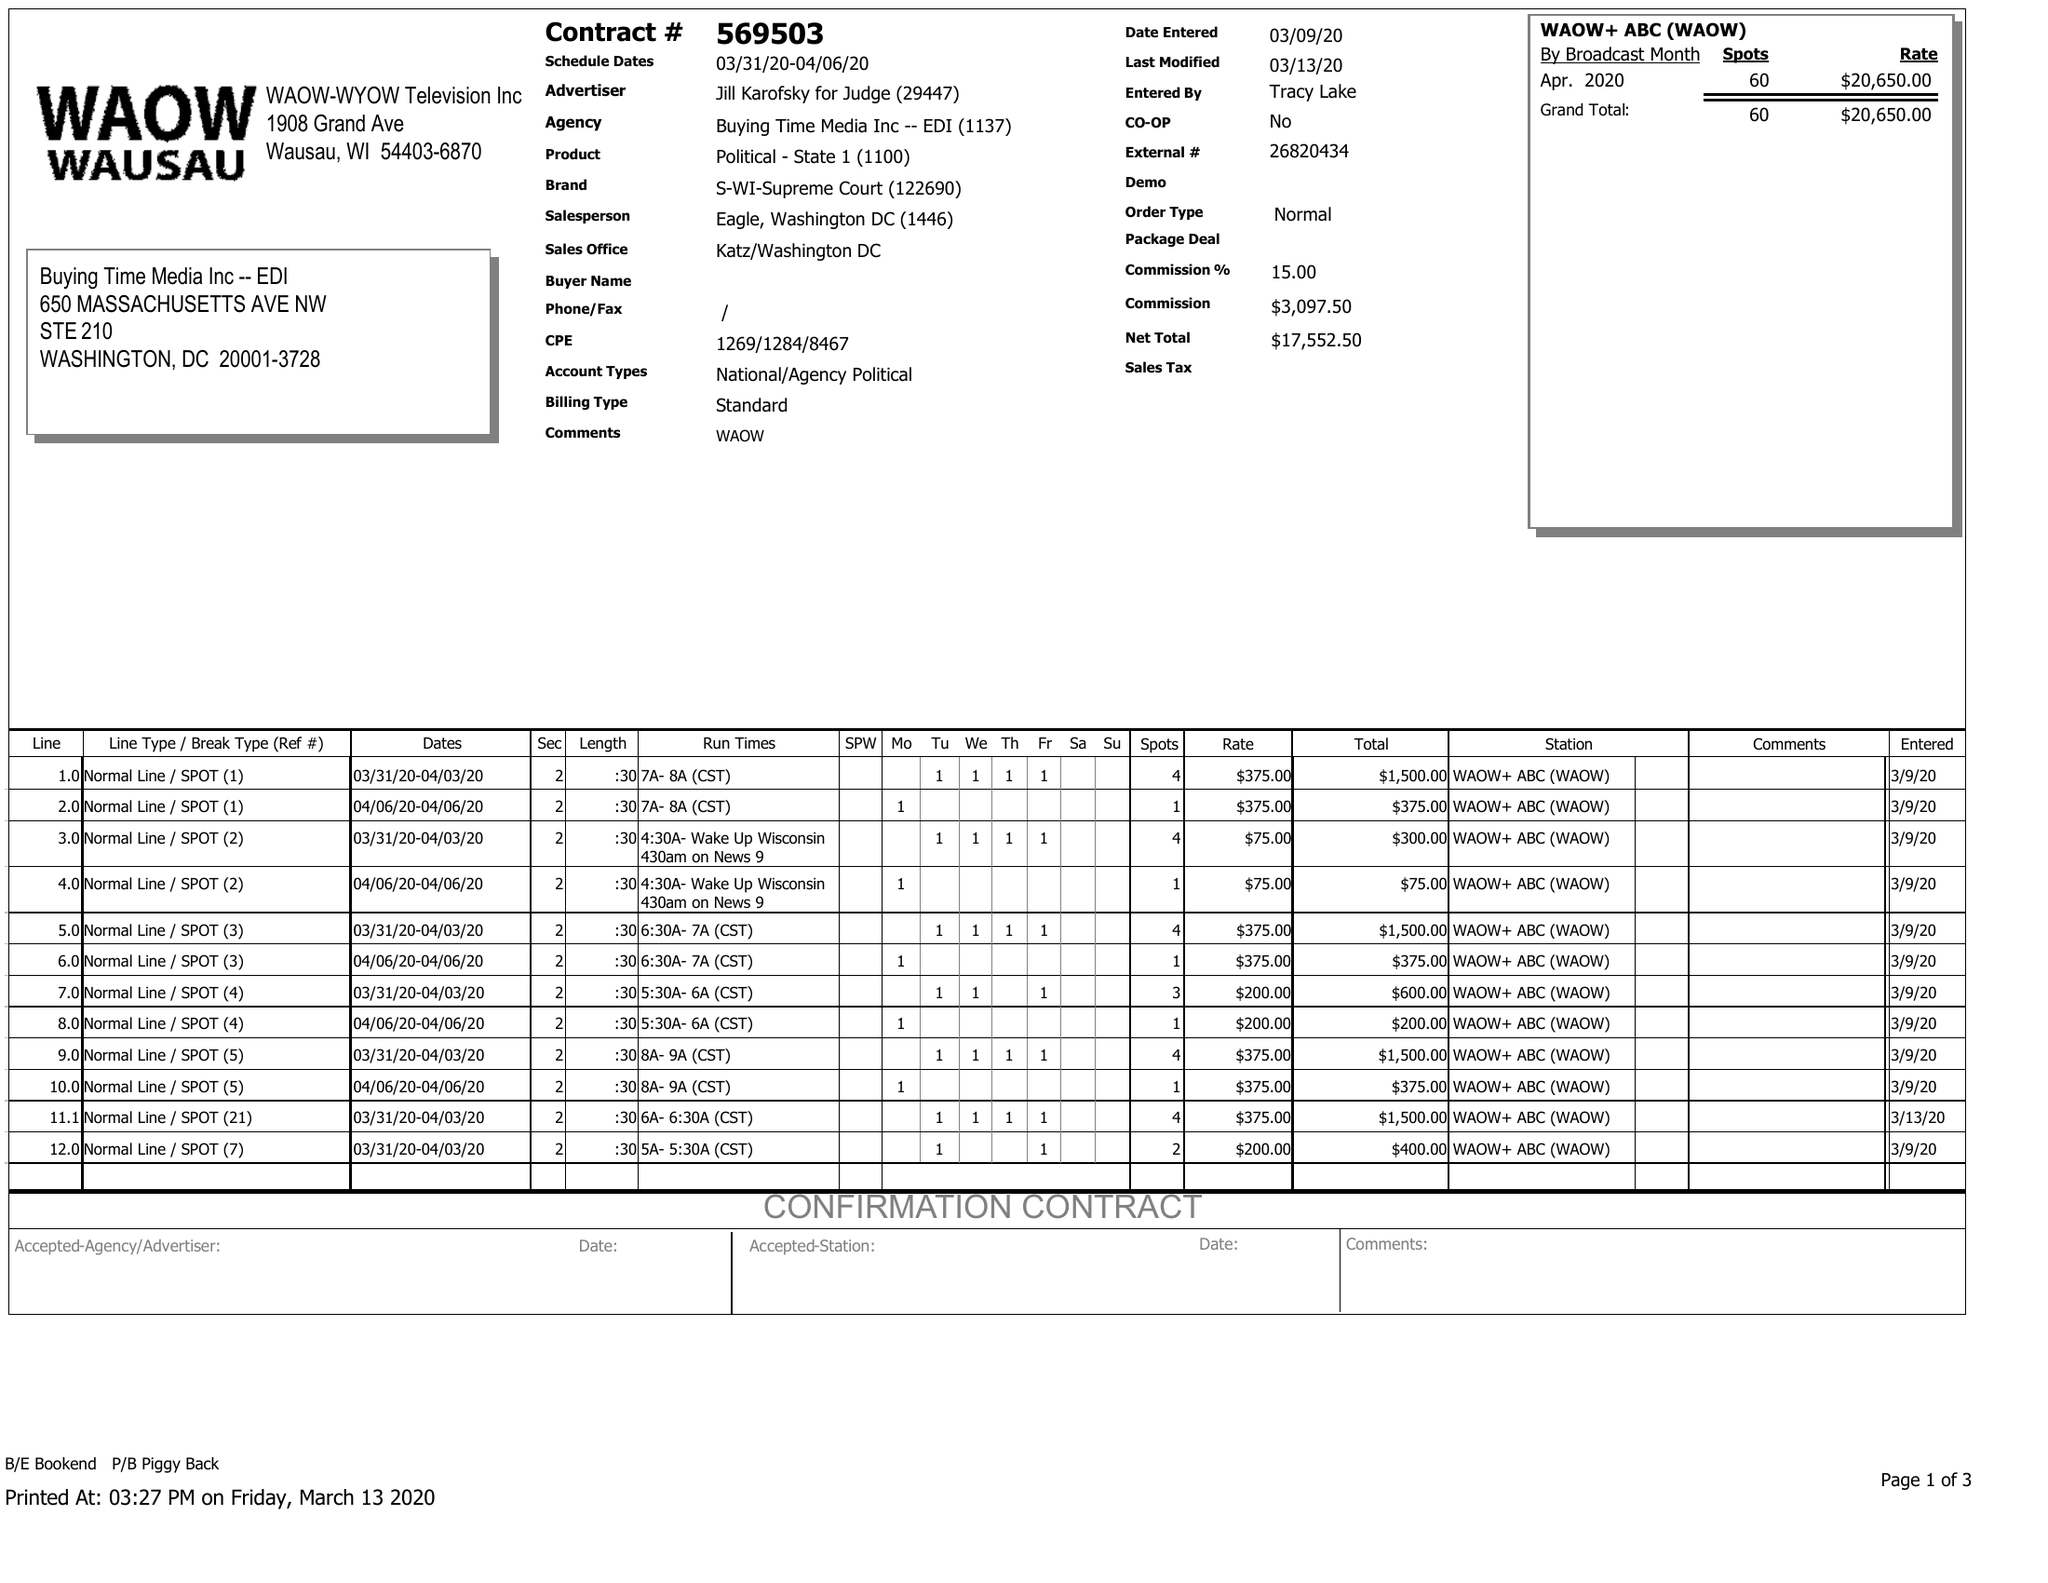What is the value for the advertiser?
Answer the question using a single word or phrase. JILL KAROFSKY FOR JUDGE 